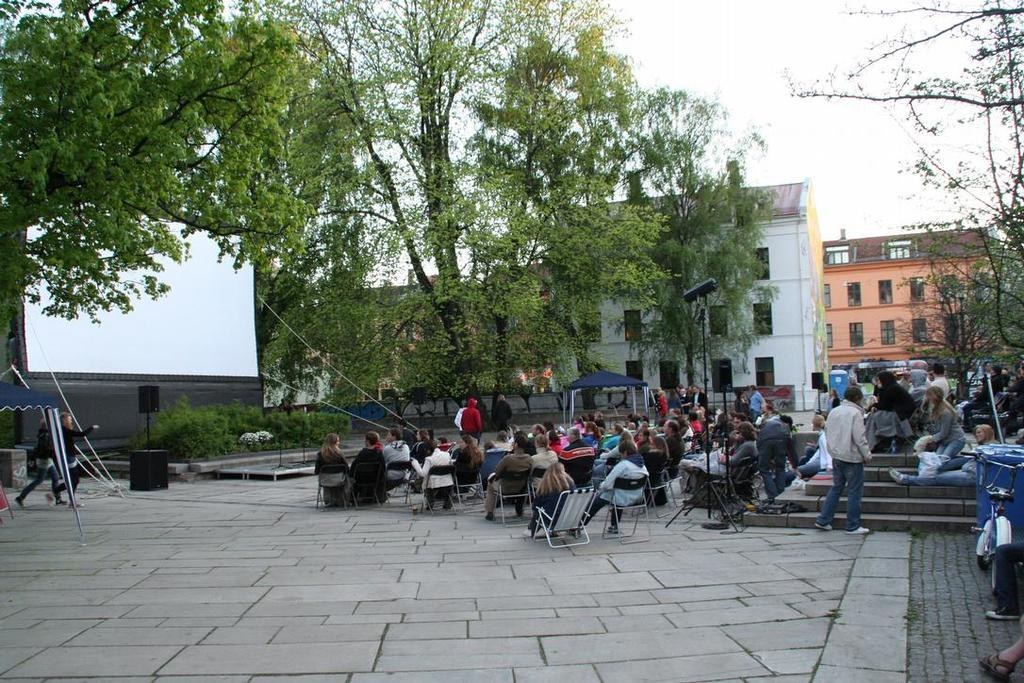What are the people in the image doing? The people in the image are sitting on chairs. What can be seen in the distance behind the people? There are buildings and trees visible in the background of the image. What is the purpose of the screen in the image? The purpose of the screen is not specified in the facts, but it is present in the image. How does the carriage fit into the image? There is no carriage present in the image. 